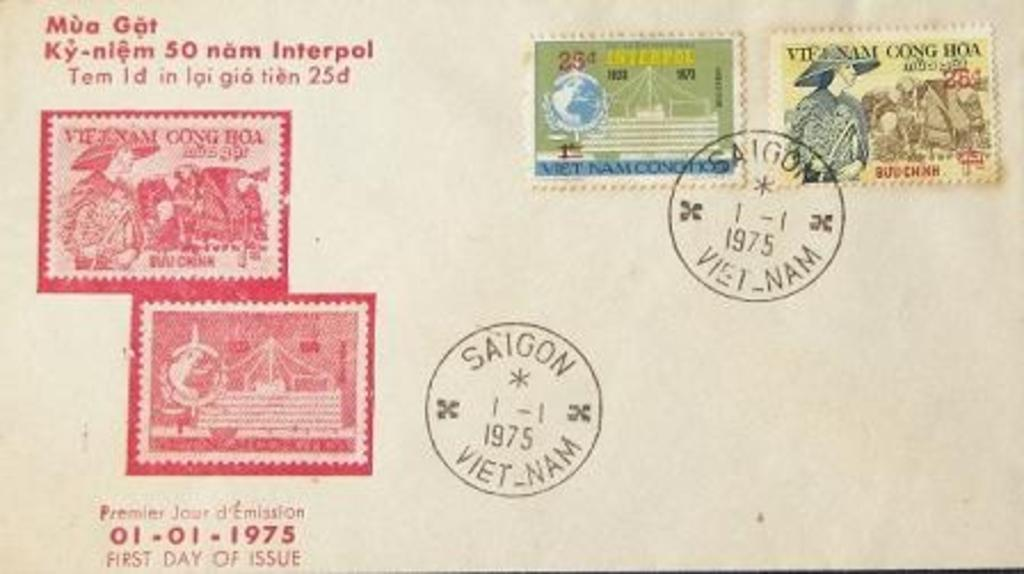<image>
Summarize the visual content of the image. The back of a post card stamped Saigon 1975 when stamps where 25 cents. 